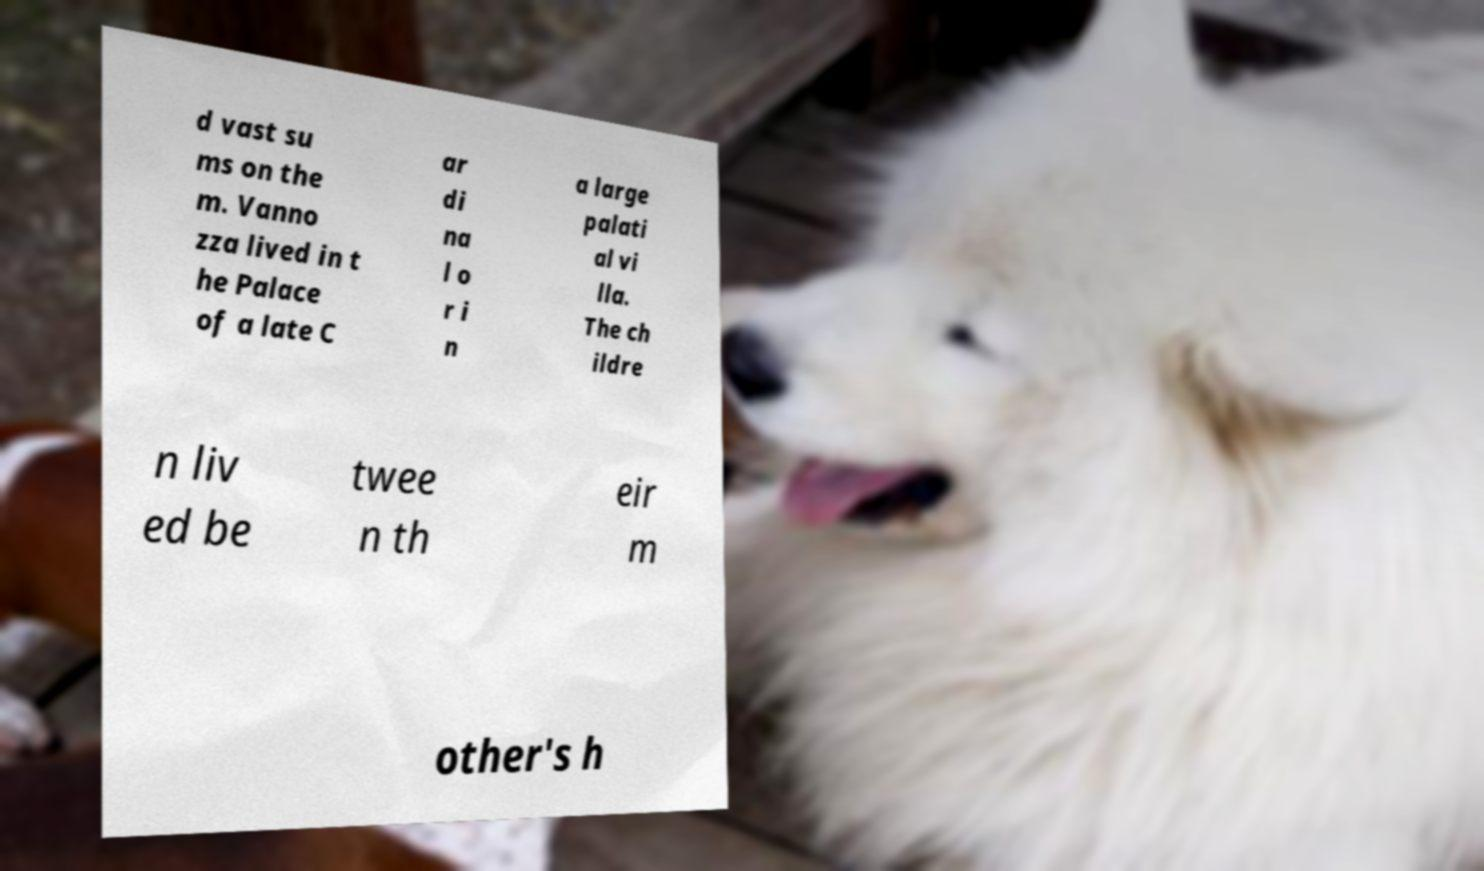Can you accurately transcribe the text from the provided image for me? d vast su ms on the m. Vanno zza lived in t he Palace of a late C ar di na l o r i n a large palati al vi lla. The ch ildre n liv ed be twee n th eir m other's h 